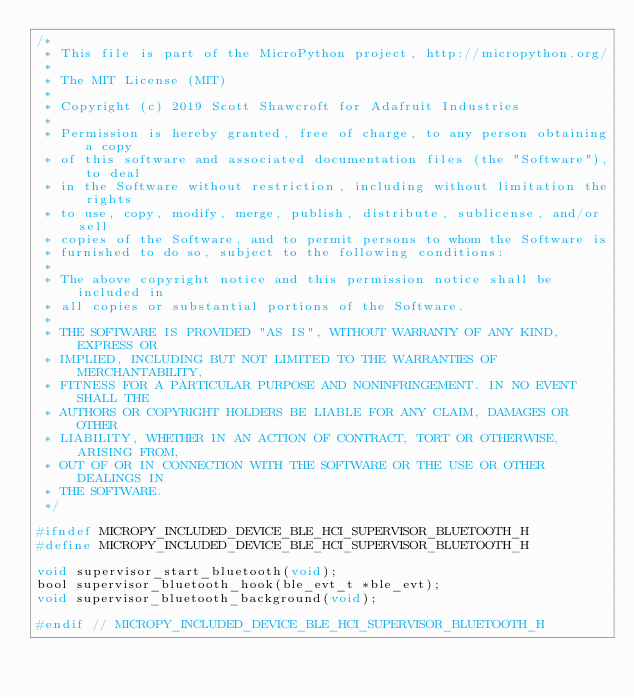<code> <loc_0><loc_0><loc_500><loc_500><_C_>/*
 * This file is part of the MicroPython project, http://micropython.org/
 *
 * The MIT License (MIT)
 *
 * Copyright (c) 2019 Scott Shawcroft for Adafruit Industries
 *
 * Permission is hereby granted, free of charge, to any person obtaining a copy
 * of this software and associated documentation files (the "Software"), to deal
 * in the Software without restriction, including without limitation the rights
 * to use, copy, modify, merge, publish, distribute, sublicense, and/or sell
 * copies of the Software, and to permit persons to whom the Software is
 * furnished to do so, subject to the following conditions:
 *
 * The above copyright notice and this permission notice shall be included in
 * all copies or substantial portions of the Software.
 *
 * THE SOFTWARE IS PROVIDED "AS IS", WITHOUT WARRANTY OF ANY KIND, EXPRESS OR
 * IMPLIED, INCLUDING BUT NOT LIMITED TO THE WARRANTIES OF MERCHANTABILITY,
 * FITNESS FOR A PARTICULAR PURPOSE AND NONINFRINGEMENT. IN NO EVENT SHALL THE
 * AUTHORS OR COPYRIGHT HOLDERS BE LIABLE FOR ANY CLAIM, DAMAGES OR OTHER
 * LIABILITY, WHETHER IN AN ACTION OF CONTRACT, TORT OR OTHERWISE, ARISING FROM,
 * OUT OF OR IN CONNECTION WITH THE SOFTWARE OR THE USE OR OTHER DEALINGS IN
 * THE SOFTWARE.
 */

#ifndef MICROPY_INCLUDED_DEVICE_BLE_HCI_SUPERVISOR_BLUETOOTH_H
#define MICROPY_INCLUDED_DEVICE_BLE_HCI_SUPERVISOR_BLUETOOTH_H

void supervisor_start_bluetooth(void);
bool supervisor_bluetooth_hook(ble_evt_t *ble_evt);
void supervisor_bluetooth_background(void);

#endif // MICROPY_INCLUDED_DEVICE_BLE_HCI_SUPERVISOR_BLUETOOTH_H
</code> 